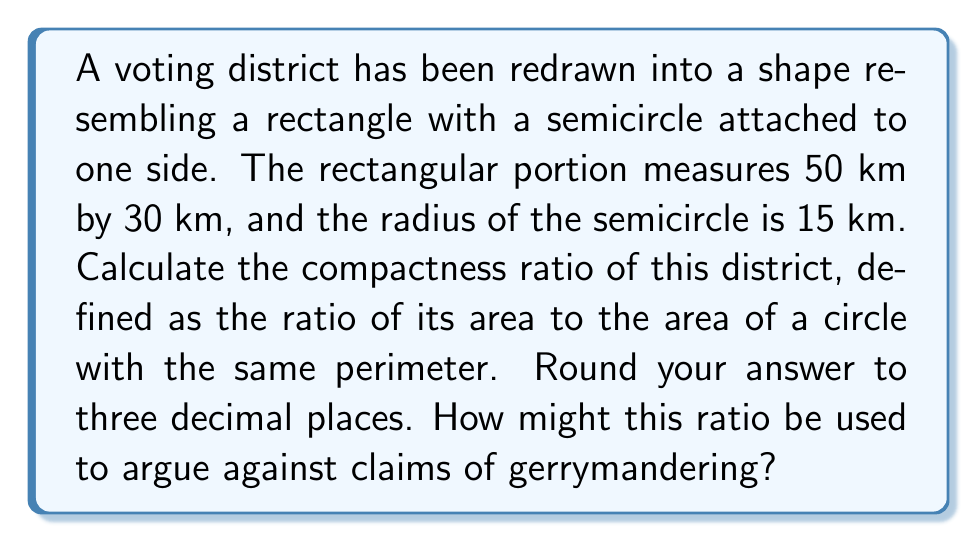What is the answer to this math problem? Let's approach this step-by-step:

1) First, calculate the area of the district:
   Area of rectangle: $A_r = 50 \times 30 = 1500$ km²
   Area of semicircle: $A_s = \frac{1}{2} \pi r^2 = \frac{1}{2} \pi 15^2 \approx 353.43$ km²
   Total area: $A_t = 1500 + 353.43 = 1853.43$ km²

2) Now, calculate the perimeter of the district:
   Perimeter of rectangle (excluding the side with semicircle): $2(50) + 30 = 130$ km
   Perimeter of semicircle: $\pi r = \pi 15 \approx 47.12$ km
   Total perimeter: $P_t = 130 + 47.12 = 177.12$ km

3) Calculate the area of a circle with this perimeter:
   $r = \frac{P_t}{2\pi} = \frac{177.12}{2\pi} \approx 28.19$ km
   Area: $A_c = \pi r^2 = \pi (28.19)^2 \approx 2497.69$ km²

4) Calculate the compactness ratio:
   Ratio = $\frac{\text{Area of district}}{\text{Area of circle}} = \frac{1853.43}{2497.69} \approx 0.742$

5) This ratio can be used to argue against claims of gerrymandering by asserting that the district's shape is relatively compact. A ratio closer to 1 indicates a more circular, and thus potentially less gerrymandered, shape. The government could argue that this ratio of 0.742 is reasonably high, suggesting the district's shape is not overly irregular or manipulated.
Answer: 0.742 